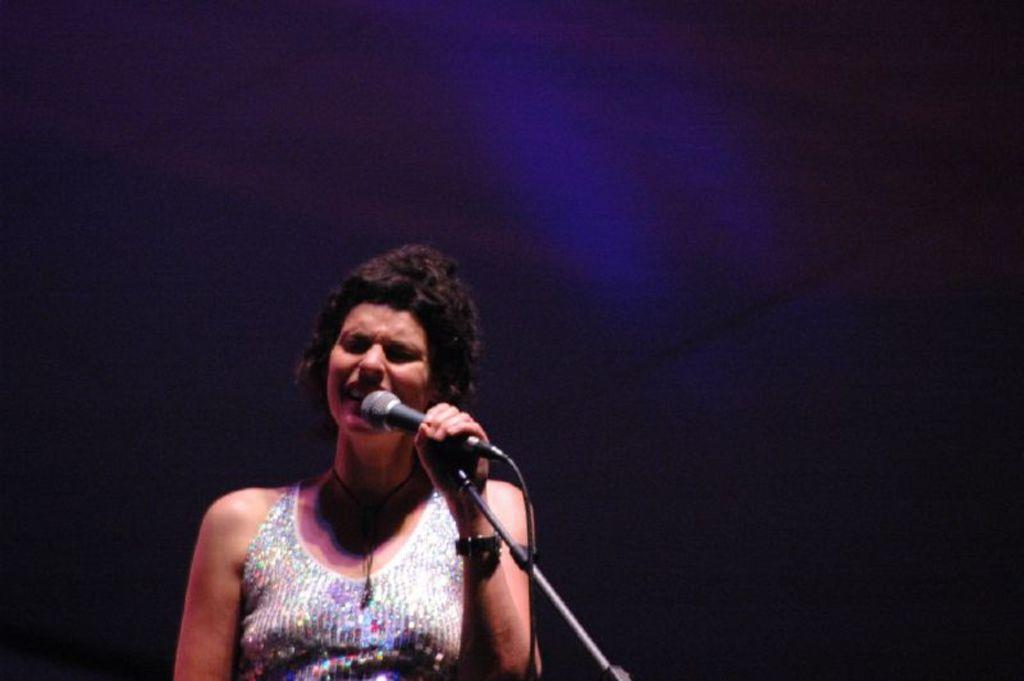Who is the main subject in the image? There is a woman in the image. What is the woman doing in the image? The woman is singing. What equipment is the woman using while singing? The woman is in front of a microphone and stand. How would you describe the lighting in the image? The background of the image is dark. Can you see the woman's bun while she is singing in the image? There is no mention of a bun in the provided facts, and it cannot be determined from the image. --- Facts: 1. There is a car in the image. 2. The car is red. 3. The car has four wheels. 4. There are people in the car. 5. The car is parked on the street. Absurd Topics: parrot, dance, mountain Conversation: What is the main subject in the image? There is a car in the image. What color is the car? The car is red. How many wheels does the car have? The car has four wheels. Are there any passengers in the car? Yes, there are people in the car. Where is the car located in the image? The car is parked on the street. Reasoning: Let's think step by step in order to produce the conversation. We start by identifying the main subject in the image, which is the car. Then, we describe the car's color and the number of wheels it has. Next, we mention the presence of passengers in the car. Finally, we describe the car's location, which is parked on the street. Each question is designed to elicit a specific detail about the image that is known from the provided facts. Absurd Question/Answer: Can you see a parrot dancing on top of the mountain in the image? There is no mention of a parrot, dancing, or a mountain in the provided facts, and they cannot be determined from the image. 